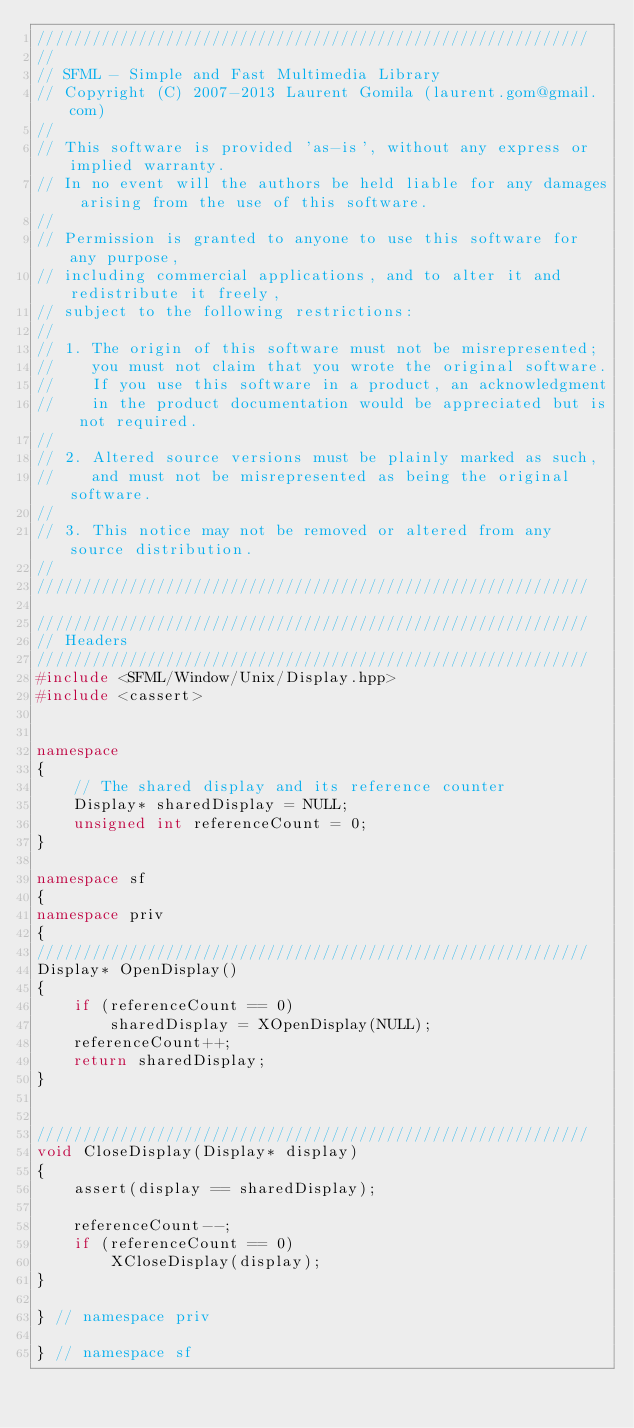<code> <loc_0><loc_0><loc_500><loc_500><_C++_>////////////////////////////////////////////////////////////
//
// SFML - Simple and Fast Multimedia Library
// Copyright (C) 2007-2013 Laurent Gomila (laurent.gom@gmail.com)
//
// This software is provided 'as-is', without any express or implied warranty.
// In no event will the authors be held liable for any damages arising from the use of this software.
//
// Permission is granted to anyone to use this software for any purpose,
// including commercial applications, and to alter it and redistribute it freely,
// subject to the following restrictions:
//
// 1. The origin of this software must not be misrepresented;
//    you must not claim that you wrote the original software.
//    If you use this software in a product, an acknowledgment
//    in the product documentation would be appreciated but is not required.
//
// 2. Altered source versions must be plainly marked as such,
//    and must not be misrepresented as being the original software.
//
// 3. This notice may not be removed or altered from any source distribution.
//
////////////////////////////////////////////////////////////

////////////////////////////////////////////////////////////
// Headers
////////////////////////////////////////////////////////////
#include <SFML/Window/Unix/Display.hpp>
#include <cassert>


namespace
{
    // The shared display and its reference counter
    Display* sharedDisplay = NULL;
    unsigned int referenceCount = 0;
}

namespace sf
{
namespace priv
{
////////////////////////////////////////////////////////////
Display* OpenDisplay()
{
    if (referenceCount == 0)
        sharedDisplay = XOpenDisplay(NULL);
    referenceCount++;
    return sharedDisplay;
}


////////////////////////////////////////////////////////////
void CloseDisplay(Display* display)
{
    assert(display == sharedDisplay);

    referenceCount--;
    if (referenceCount == 0)
        XCloseDisplay(display);
}

} // namespace priv

} // namespace sf
</code> 